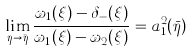Convert formula to latex. <formula><loc_0><loc_0><loc_500><loc_500>\lim _ { \eta \to \bar { \eta } } \frac { \omega _ { 1 } ( \xi ) - \delta _ { - } ( \xi ) } { \omega _ { 1 } ( \xi ) - \omega _ { 2 } ( \xi ) } = a _ { 1 } ^ { 2 } ( \bar { \eta } )</formula> 